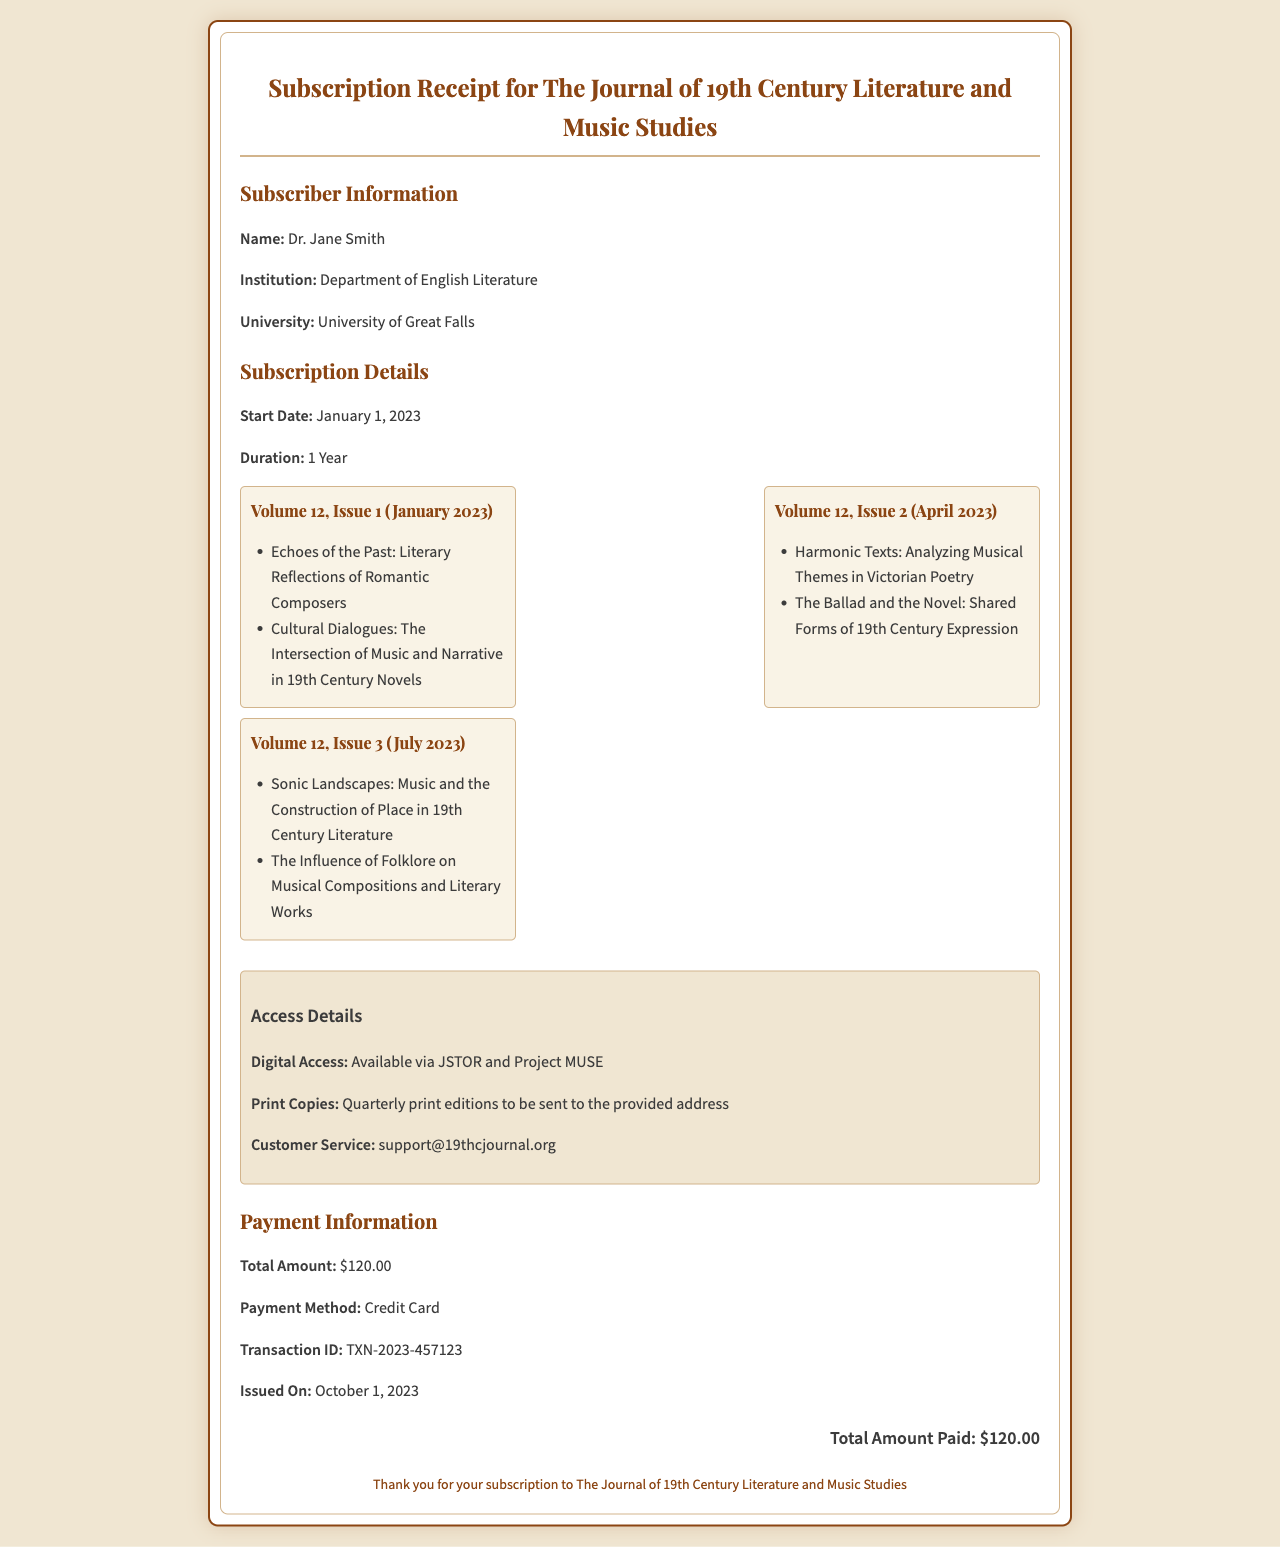What is the name of the journal? The name of the journal is stated at the top of the receipt.
Answer: The Journal of 19th Century Literature and Music Studies Who is the subscriber? The subscriber's name is listed in the subscriber information section.
Answer: Dr. Jane Smith What is the start date of the subscription? The start date is specified in the subscription details section of the receipt.
Answer: January 1, 2023 How many issues are included in the subscription? The number of issues is reflected in the subscription details, with three issues listed.
Answer: 3 What is the total amount paid? The total amount paid is clearly indicated in the payment information section.
Answer: $120.00 What is the payment method used? The payment method is mentioned in the payment information section.
Answer: Credit Card What is the email for customer service? The customer service email is listed in the access details section of the receipt.
Answer: support@19thcjournal.org What is the transaction ID? The transaction ID can be found in the payment information section of the receipt.
Answer: TXN-2023-457123 When was the receipt issued? The issue date is provided in the payment information section of the document.
Answer: October 1, 2023 